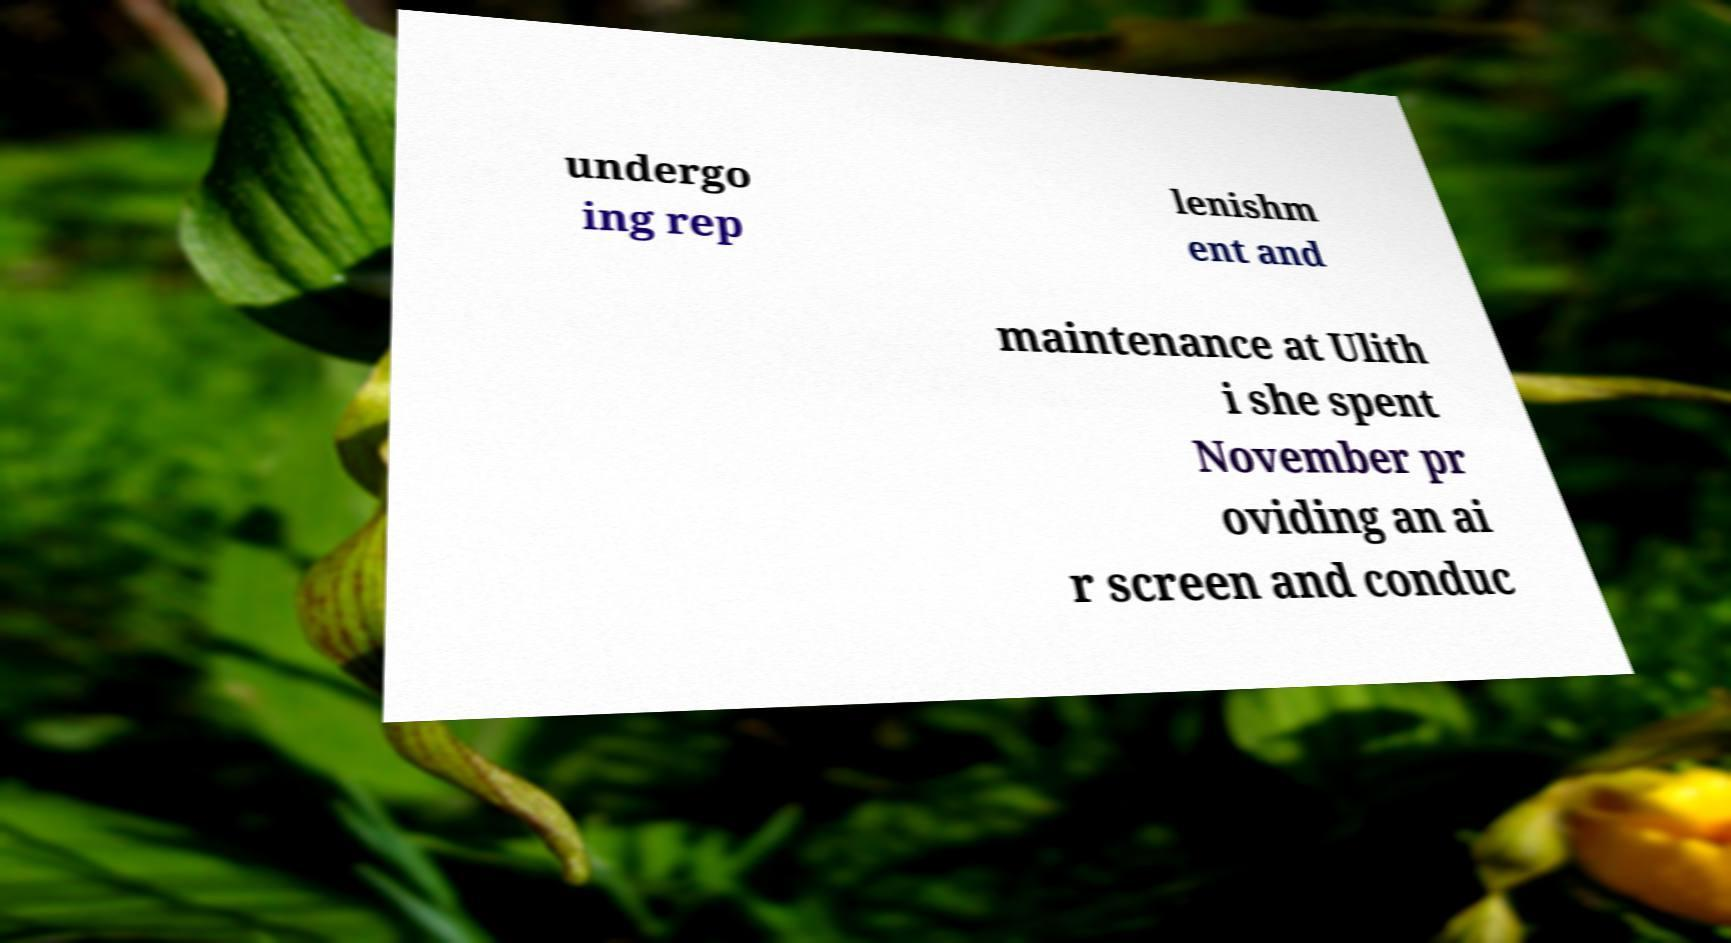For documentation purposes, I need the text within this image transcribed. Could you provide that? undergo ing rep lenishm ent and maintenance at Ulith i she spent November pr oviding an ai r screen and conduc 